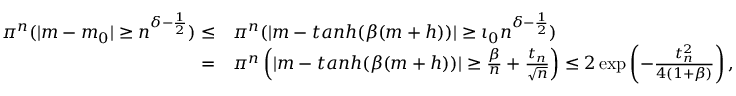<formula> <loc_0><loc_0><loc_500><loc_500>\begin{array} { r l } { \pi ^ { n } ( | m - m _ { 0 } | \geq n ^ { \delta - \frac { 1 } { 2 } } ) \leq } & { \pi ^ { n } ( | m - t a n h ( \beta ( m + h ) ) | \geq \iota _ { 0 } n ^ { \delta - \frac { 1 } { 2 } } ) } \\ { = } & { \pi ^ { n } \left ( | m - t a n h ( \beta ( m + h ) ) | \geq \frac { \beta } { n } + \frac { t _ { n } } { \sqrt { n } } \right ) \leq 2 \exp \left ( - \frac { t _ { n } ^ { 2 } } { 4 ( 1 + \beta ) } \right ) , } \end{array}</formula> 